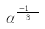<formula> <loc_0><loc_0><loc_500><loc_500>\alpha ^ { \frac { N \pi - 1 } { 3 } }</formula> 